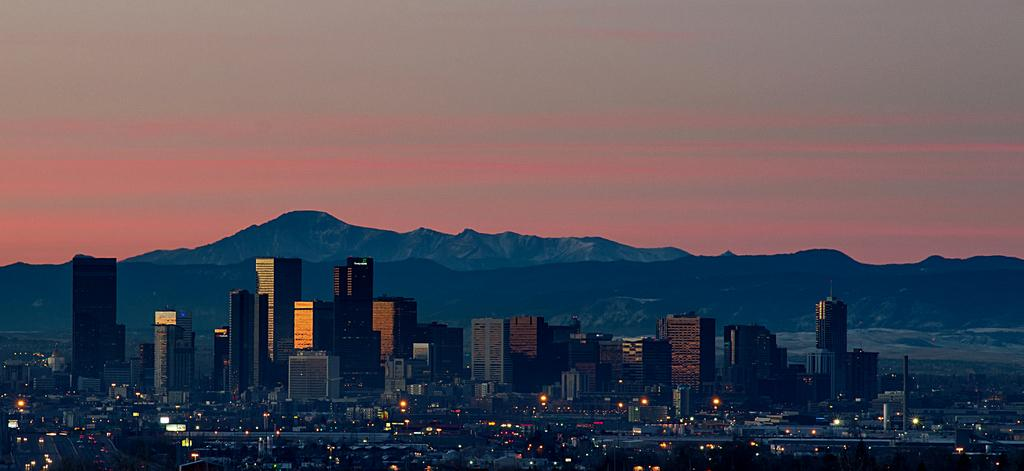What type of structures can be seen in the image? There are buildings in the image. What else is visible in the image besides the buildings? There are lights, poles, mountains, and the sky visible in the image. Can you describe the poles in the image? The poles are likely used for supporting lights or other infrastructure. What is the natural feature visible in the image? There are mountains in the image. How does the swing work in the image? There is no swing present in the image. 